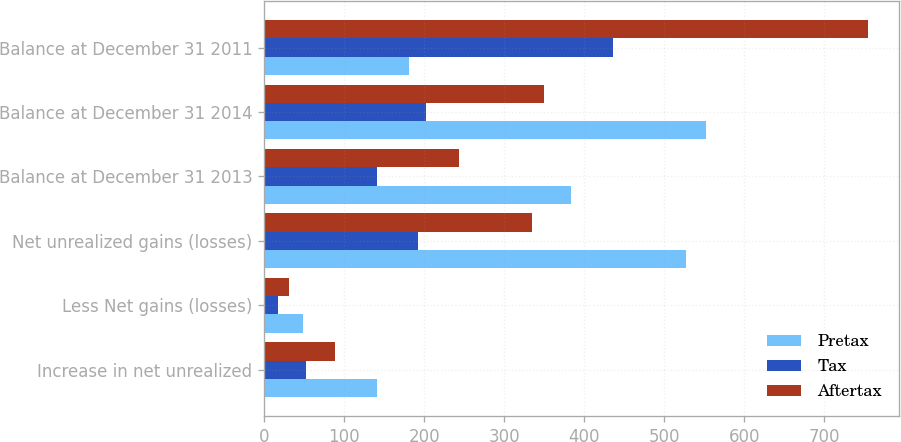Convert chart. <chart><loc_0><loc_0><loc_500><loc_500><stacked_bar_chart><ecel><fcel>Increase in net unrealized<fcel>Less Net gains (losses)<fcel>Net unrealized gains (losses)<fcel>Balance at December 31 2013<fcel>Balance at December 31 2014<fcel>Balance at December 31 2011<nl><fcel>Pretax<fcel>141<fcel>49<fcel>527<fcel>384<fcel>552<fcel>181<nl><fcel>Tax<fcel>52<fcel>18<fcel>192<fcel>141<fcel>202<fcel>436<nl><fcel>Aftertax<fcel>89<fcel>31<fcel>335<fcel>243<fcel>350<fcel>755<nl></chart> 